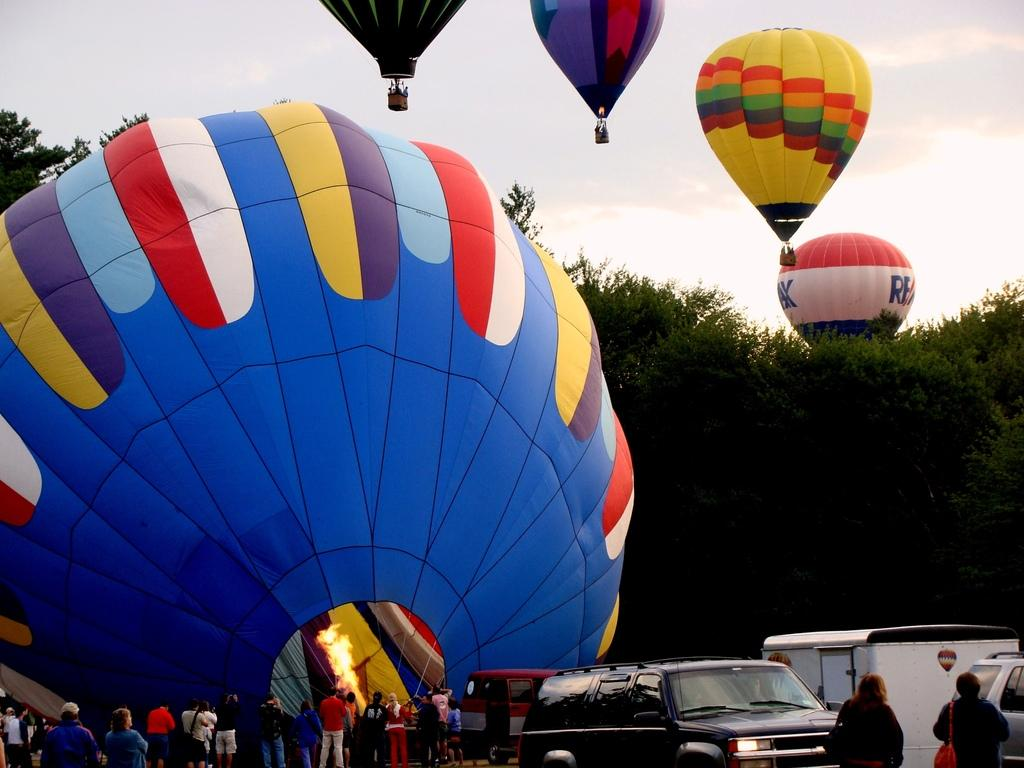Who or what can be seen in the image? There are people in the image. What else is present in the image besides people? There are vehicles and hot air balloons in the image. Are there any natural elements in the image? Yes, there are trees in the image. What can be seen in the background of the image? The sky is visible in the background of the image. What type of corn can be seen growing in the image? There is no corn present in the image. 